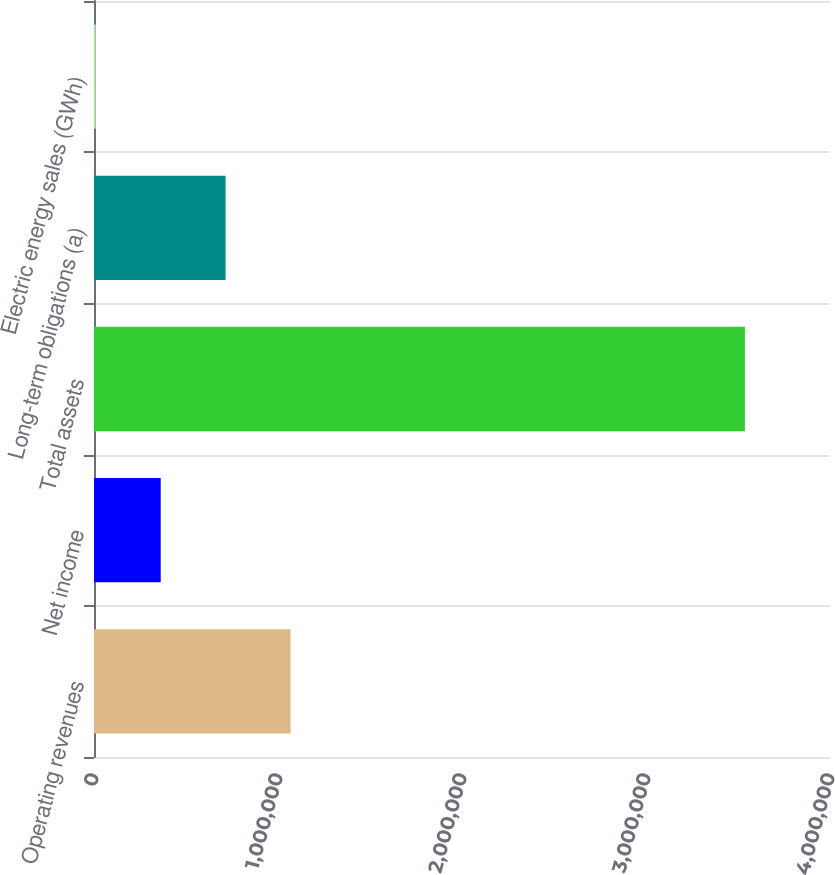Convert chart to OTSL. <chart><loc_0><loc_0><loc_500><loc_500><bar_chart><fcel>Operating revenues<fcel>Net income<fcel>Total assets<fcel>Long-term obligations (a)<fcel>Electric energy sales (GWh)<nl><fcel>1.06808e+06<fcel>362556<fcel>3.53741e+06<fcel>715318<fcel>9794<nl></chart> 